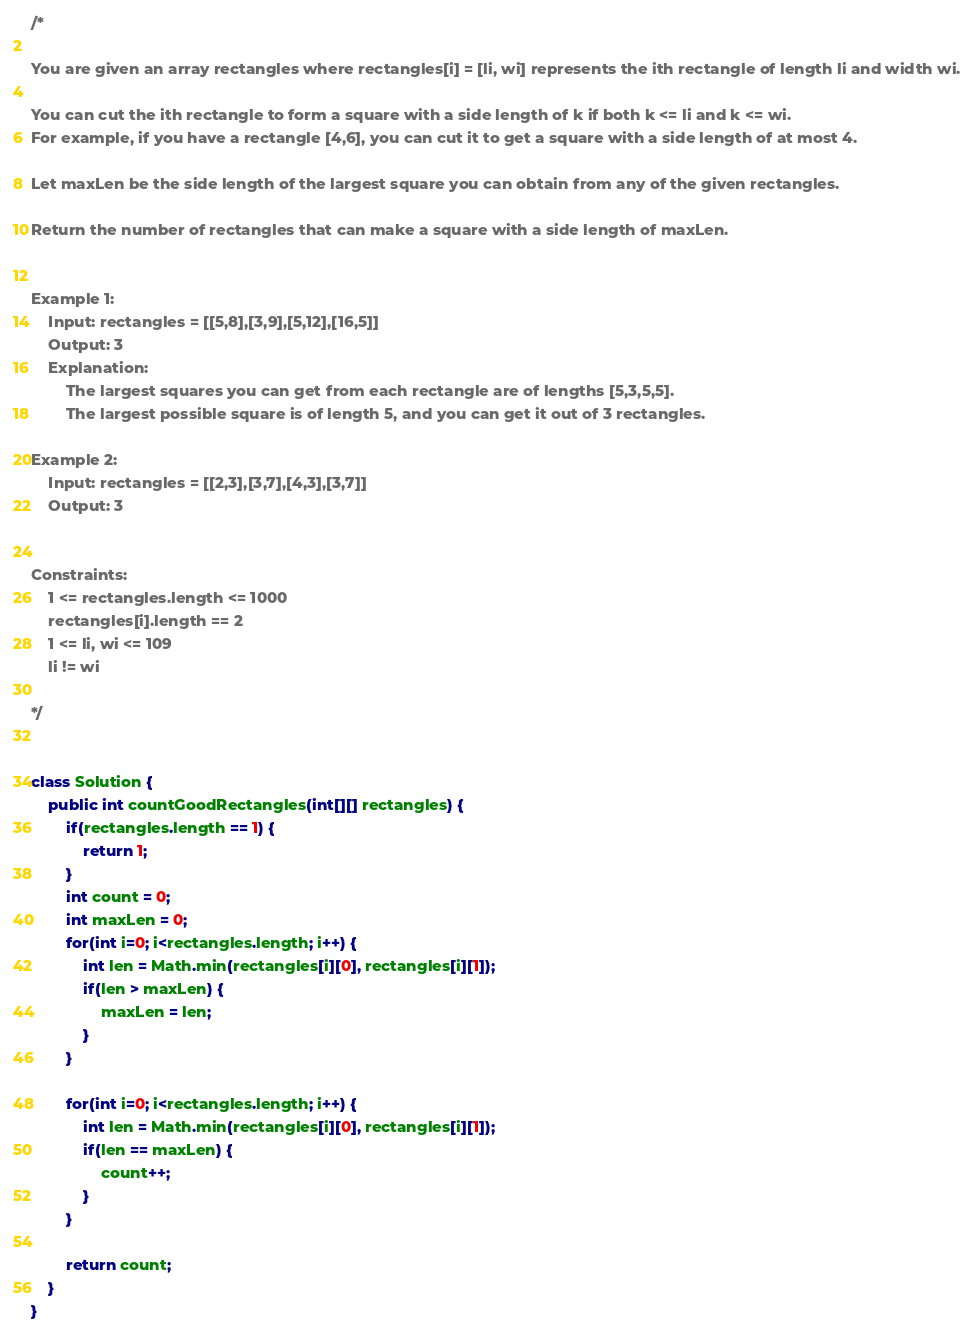<code> <loc_0><loc_0><loc_500><loc_500><_Java_>/*

You are given an array rectangles where rectangles[i] = [li, wi] represents the ith rectangle of length li and width wi.

You can cut the ith rectangle to form a square with a side length of k if both k <= li and k <= wi. 
For example, if you have a rectangle [4,6], you can cut it to get a square with a side length of at most 4.

Let maxLen be the side length of the largest square you can obtain from any of the given rectangles.

Return the number of rectangles that can make a square with a side length of maxLen.

 
Example 1:
    Input: rectangles = [[5,8],[3,9],[5,12],[16,5]]
    Output: 3
    Explanation: 
        The largest squares you can get from each rectangle are of lengths [5,3,5,5].
        The largest possible square is of length 5, and you can get it out of 3 rectangles.

Example 2:
    Input: rectangles = [[2,3],[3,7],[4,3],[3,7]]
    Output: 3
 

Constraints:
    1 <= rectangles.length <= 1000
    rectangles[i].length == 2
    1 <= li, wi <= 109
    li != wi

*/


class Solution {
    public int countGoodRectangles(int[][] rectangles) {
        if(rectangles.length == 1) {
            return 1;
        }
        int count = 0;
        int maxLen = 0;
        for(int i=0; i<rectangles.length; i++) {
            int len = Math.min(rectangles[i][0], rectangles[i][1]);
            if(len > maxLen) {
                maxLen = len; 
            }
        }
        
        for(int i=0; i<rectangles.length; i++) {
            int len = Math.min(rectangles[i][0], rectangles[i][1]);
            if(len == maxLen) {
                count++; 
            }
        }
        
        return count;
    }
}</code> 